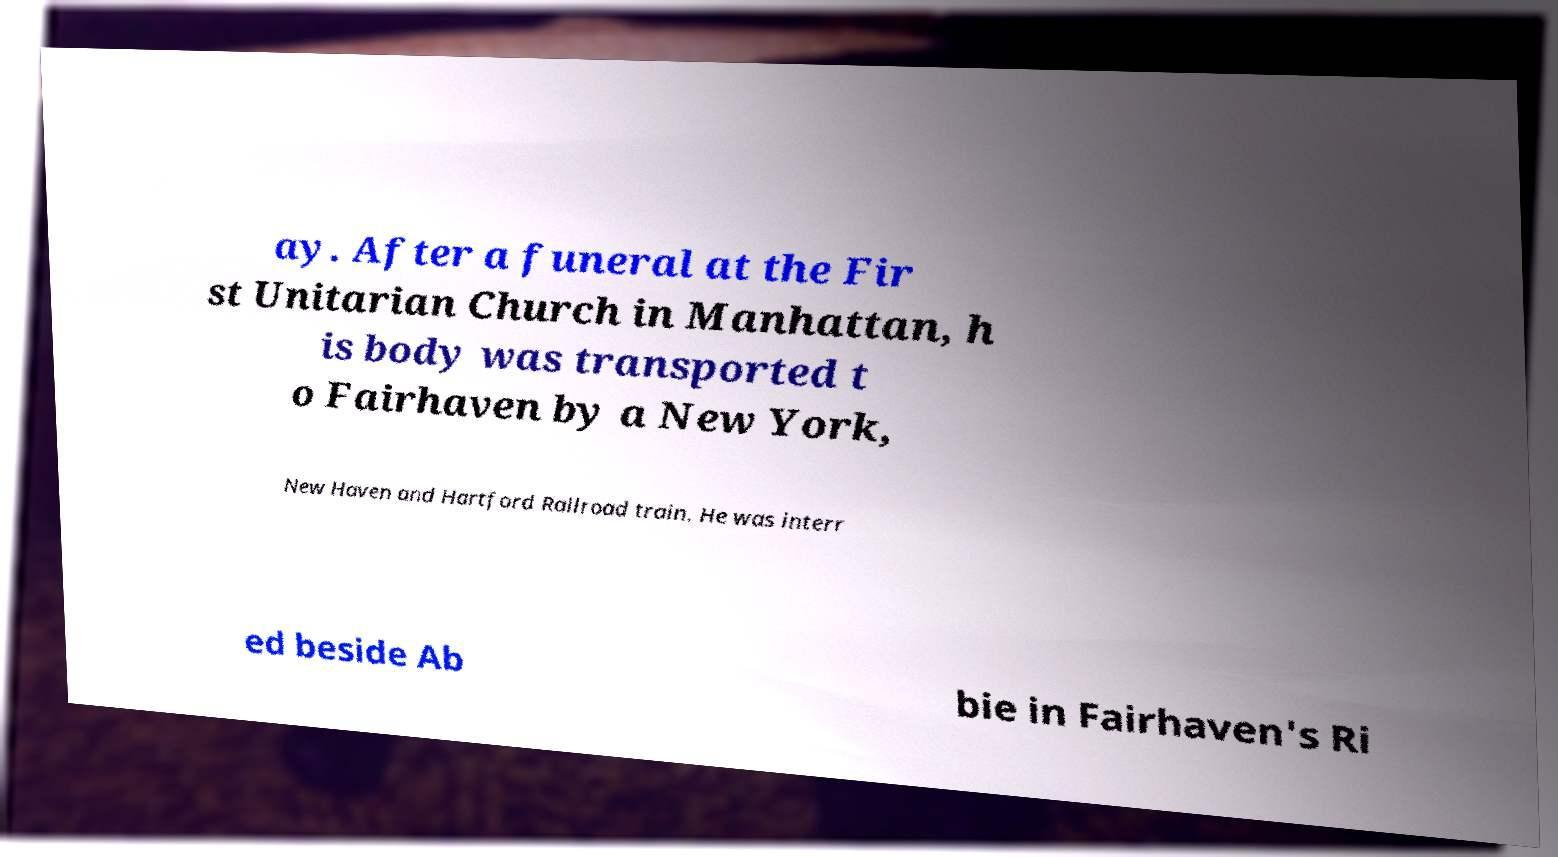I need the written content from this picture converted into text. Can you do that? ay. After a funeral at the Fir st Unitarian Church in Manhattan, h is body was transported t o Fairhaven by a New York, New Haven and Hartford Railroad train. He was interr ed beside Ab bie in Fairhaven's Ri 